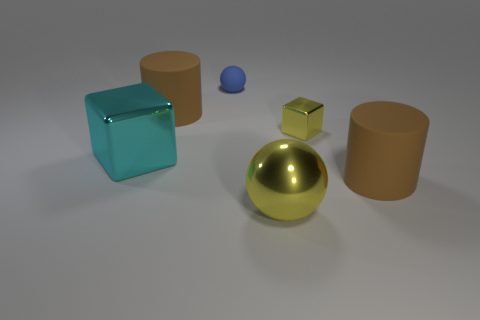Add 2 small spheres. How many objects exist? 8 Subtract all cylinders. How many objects are left? 4 Subtract all large cylinders. Subtract all brown rubber things. How many objects are left? 2 Add 6 small yellow metal blocks. How many small yellow metal blocks are left? 7 Add 1 cyan metal things. How many cyan metal things exist? 2 Subtract 0 purple cylinders. How many objects are left? 6 